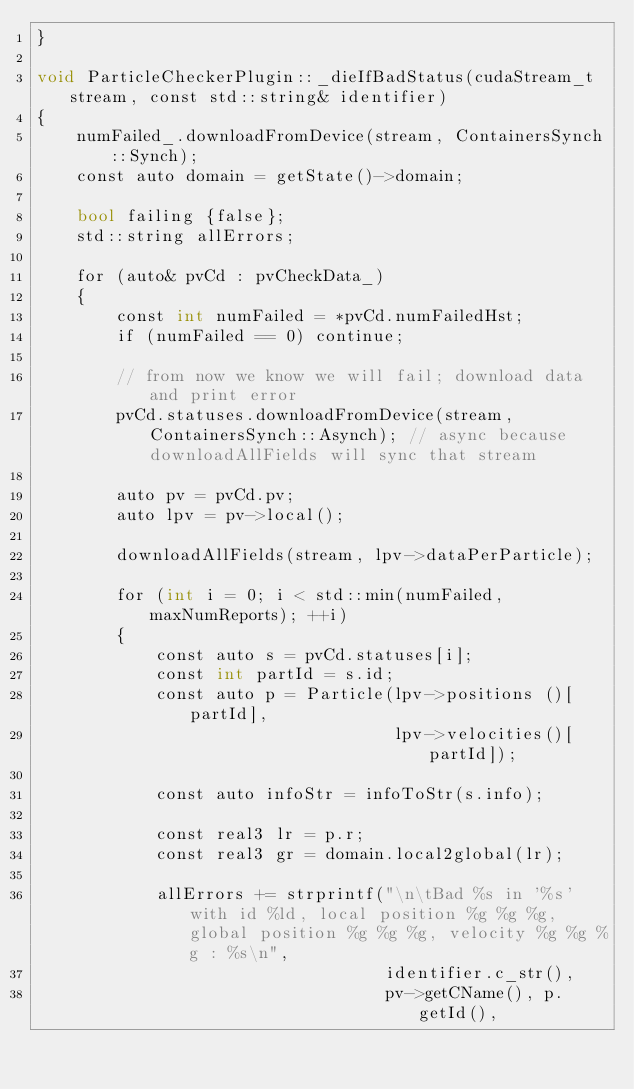<code> <loc_0><loc_0><loc_500><loc_500><_Cuda_>}

void ParticleCheckerPlugin::_dieIfBadStatus(cudaStream_t stream, const std::string& identifier)
{
    numFailed_.downloadFromDevice(stream, ContainersSynch::Synch);
    const auto domain = getState()->domain;

    bool failing {false};
    std::string allErrors;

    for (auto& pvCd : pvCheckData_)
    {
        const int numFailed = *pvCd.numFailedHst;
        if (numFailed == 0) continue;

        // from now we know we will fail; download data and print error
        pvCd.statuses.downloadFromDevice(stream, ContainersSynch::Asynch); // async because downloadAllFields will sync that stream

        auto pv = pvCd.pv;
        auto lpv = pv->local();

        downloadAllFields(stream, lpv->dataPerParticle);

        for (int i = 0; i < std::min(numFailed, maxNumReports); ++i)
        {
            const auto s = pvCd.statuses[i];
            const int partId = s.id;
            const auto p = Particle(lpv->positions ()[partId],
                                    lpv->velocities()[partId]);

            const auto infoStr = infoToStr(s.info);

            const real3 lr = p.r;
            const real3 gr = domain.local2global(lr);

            allErrors += strprintf("\n\tBad %s in '%s' with id %ld, local position %g %g %g, global position %g %g %g, velocity %g %g %g : %s\n",
                                   identifier.c_str(),
                                   pv->getCName(), p.getId(),</code> 